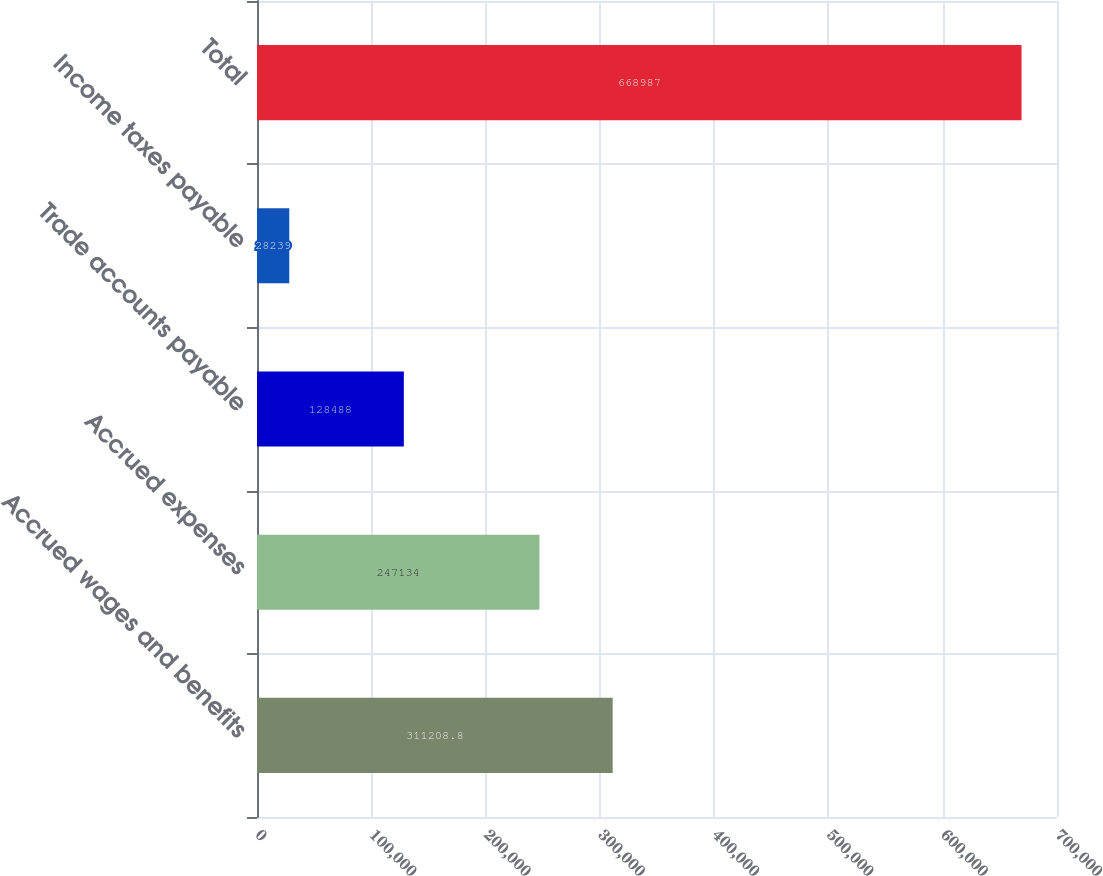<chart> <loc_0><loc_0><loc_500><loc_500><bar_chart><fcel>Accrued wages and benefits<fcel>Accrued expenses<fcel>Trade accounts payable<fcel>Income taxes payable<fcel>Total<nl><fcel>311209<fcel>247134<fcel>128488<fcel>28239<fcel>668987<nl></chart> 